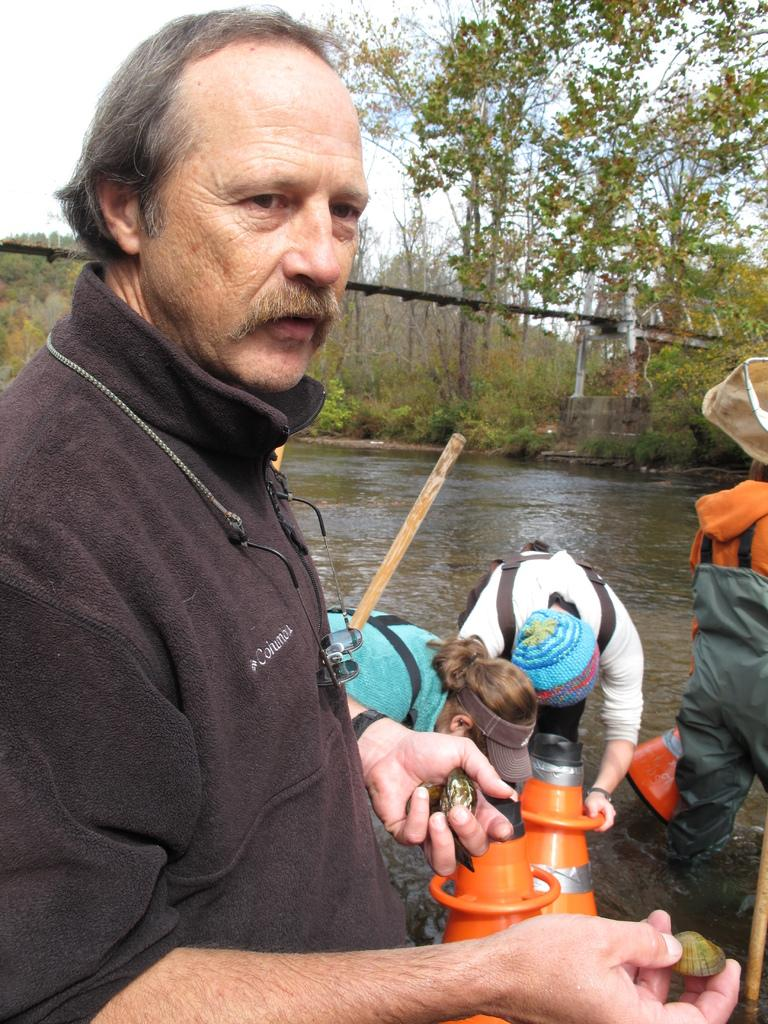How many people are present in the image? There are four persons standing in the image. What can be seen in the water in the image? There are objects in the water. What is visible in the background of the image? There are trees, a bridge, and the sky visible in the background of the image. What type of alarm is ringing in the image? There is no alarm present in the image. What is causing the neck pain in the image? There is no indication of neck pain or any related cause in the image. 